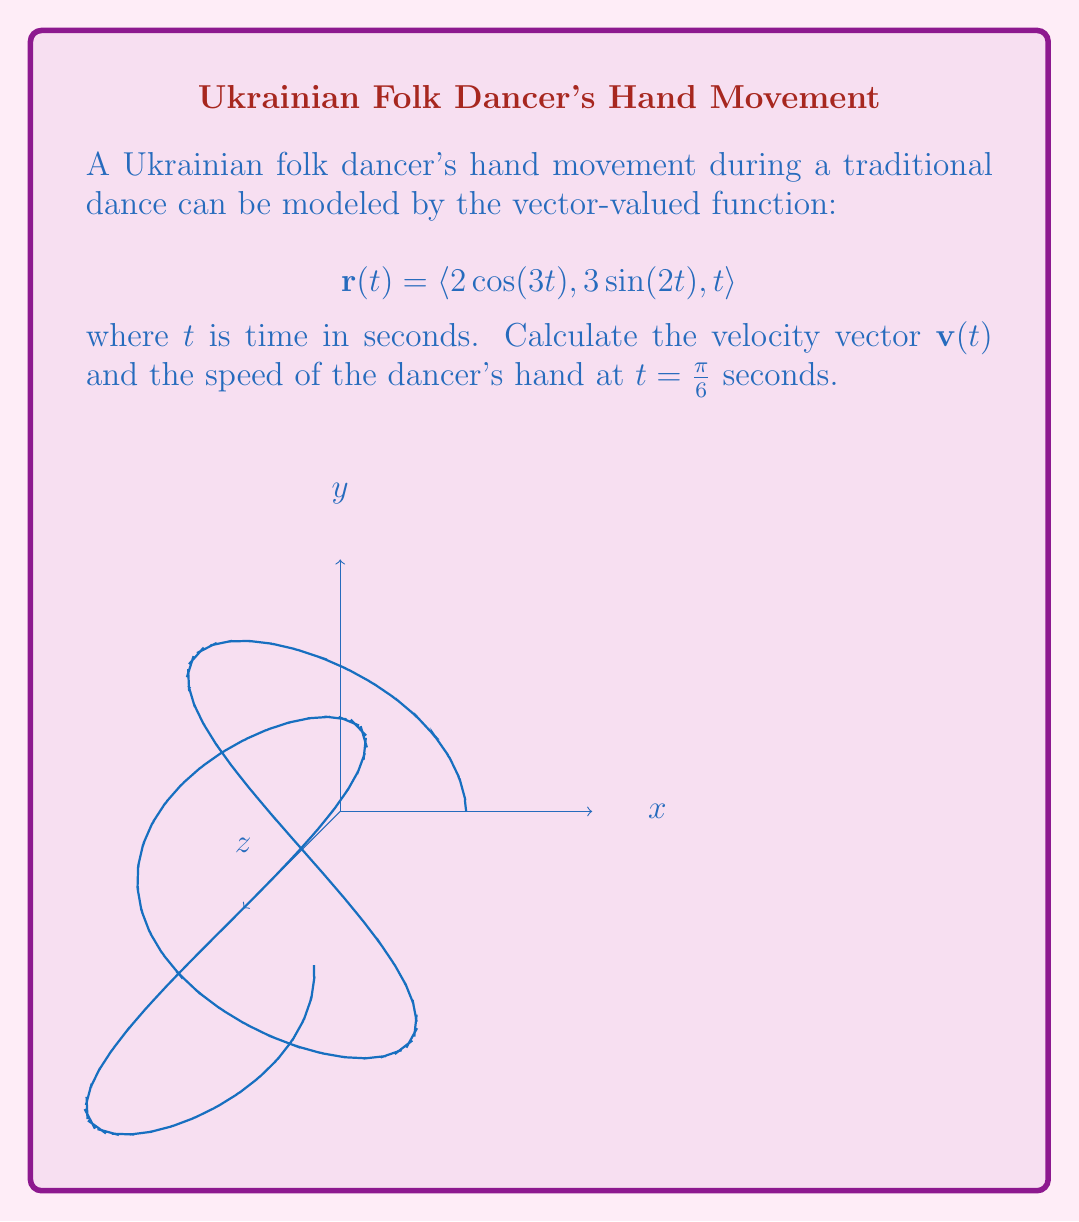Solve this math problem. To solve this problem, we'll follow these steps:

1) Find the velocity vector $\mathbf{v}(t)$ by differentiating $\mathbf{r}(t)$ with respect to $t$.

2) Evaluate $\mathbf{v}(t)$ at $t = \frac{\pi}{6}$.

3) Calculate the speed by finding the magnitude of the velocity vector.

Step 1: Finding $\mathbf{v}(t)$
The velocity vector is the derivative of the position vector:

$$\mathbf{v}(t) = \frac{d}{dt}\mathbf{r}(t) = \langle \frac{d}{dt}(2\cos(3t)), \frac{d}{dt}(3\sin(2t)), \frac{d}{dt}(t) \rangle$$

Differentiating each component:

$$\mathbf{v}(t) = \langle -6\sin(3t), 6\cos(2t), 1 \rangle$$

Step 2: Evaluating $\mathbf{v}(t)$ at $t = \frac{\pi}{6}$

$$\mathbf{v}(\frac{\pi}{6}) = \langle -6\sin(\frac{\pi}{2}), 6\cos(\frac{\pi}{3}), 1 \rangle$$

$$= \langle -6, 3, 1 \rangle$$

Step 3: Calculating the speed
The speed is the magnitude of the velocity vector:

$$\text{speed} = \|\mathbf{v}(\frac{\pi}{6})\| = \sqrt{(-6)^2 + 3^2 + 1^2}$$

$$= \sqrt{36 + 9 + 1} = \sqrt{46} \approx 6.78 \text{ units/second}$$
Answer: $\mathbf{v}(\frac{\pi}{6}) = \langle -6, 3, 1 \rangle$; speed $= \sqrt{46}$ units/second 